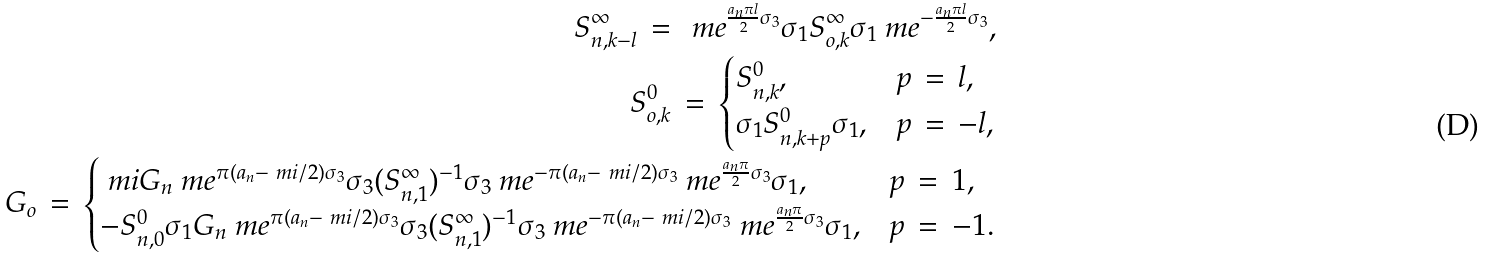<formula> <loc_0><loc_0><loc_500><loc_500>S ^ { \infty } _ { n , k - l } \, = \, \ m e ^ { \frac { a _ { n } \pi l } { 2 } \sigma _ { 3 } } \sigma _ { 1 } S ^ { \infty } _ { o , k } \sigma _ { 1 } \ m e ^ { - \frac { a _ { n } \pi l } { 2 } \sigma _ { 3 } } , \\ S ^ { 0 } _ { o , k } \, = \, \begin{cases} S ^ { 0 } _ { n , k } , & \text {$p \, = \, l$,} \\ \sigma _ { 1 } S ^ { 0 } _ { n , k + p } \sigma _ { 1 } , & \text {$p \, = \, -l$,} \end{cases} \\ G _ { o } \, = \, \begin{cases} \ m i G _ { n } \ m e ^ { \pi ( a _ { n } - \ m i / 2 ) \sigma _ { 3 } } \sigma _ { 3 } ( S ^ { \infty } _ { n , 1 } ) ^ { - 1 } \sigma _ { 3 } \ m e ^ { - \pi ( a _ { n } - \ m i / 2 ) \sigma _ { 3 } } \ m e ^ { \frac { a _ { n } \pi } { 2 } \sigma _ { 3 } } \sigma _ { 1 } , & \text {$p \, = \, 1$,} \\ - S ^ { 0 } _ { n , 0 } \sigma _ { 1 } G _ { n } \ m e ^ { \pi ( a _ { n } - \ m i / 2 ) \sigma _ { 3 } } \sigma _ { 3 } ( S ^ { \infty } _ { n , 1 } ) ^ { - 1 } \sigma _ { 3 } \ m e ^ { - \pi ( a _ { n } - \ m i / 2 ) \sigma _ { 3 } } \ m e ^ { \frac { a _ { n } \pi } { 2 } \sigma _ { 3 } } \sigma _ { 1 } , & \text {$p \, = \, -1$.} \end{cases}</formula> 